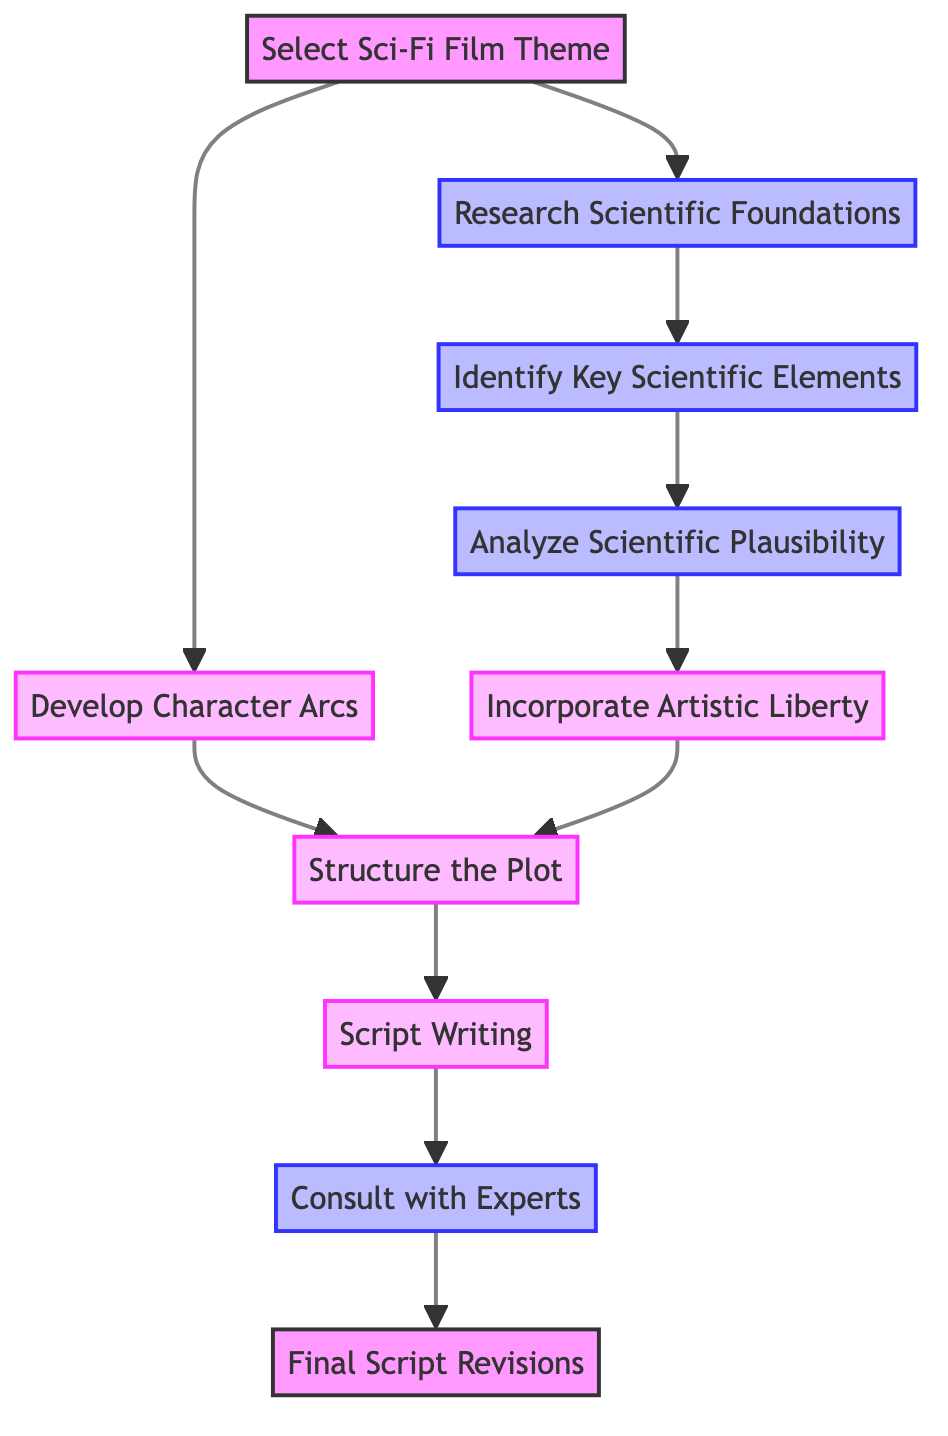What is the total number of nodes in the diagram? The diagram lists ten distinct tasks or concepts, each represented by a node labeled from 1 to 10. Therefore, by counting each node, we find there are a total of ten nodes.
Answer: 10 Which node follows "Analyze Scientific Plausibility"? From the directed edges, "Analyze Scientific Plausibility" is node 4, and the next direct connection from node 4 leads to node 5, which is "Incorporate Artistic Liberty."
Answer: Incorporate Artistic Liberty What is the primary focus of node 3? Node 3, labeled "Identify Key Scientific Elements", focuses on selecting specific scientific principles and technologies that will be central to the film's plot, such as faster-than-light travel or quantum mechanics.
Answer: Identify Key Scientific Elements How many connections lead out from "Select Sci-Fi Film Theme"? There are two directed edges leading out from "Select Sci-Fi Film Theme" (node 1): one to node 2 ("Research Scientific Foundations") and another to node 6 ("Develop Character Arcs").
Answer: 2 Which node is the final step before script revisions? The diagram shows a directed edge from node 9 ("Consult with Experts") directly leading to node 10, which is "Final Script Revisions". Hence, node 9 is the last stage before making revisions to the script.
Answer: Consult with Experts What are the two types of elements that influence the storyline as indicated in the diagram? On analyzing the diagram, it becomes clear that the elements influencing the storyline include both scientific elements (from nodes like Research Scientific Foundations) and artistic decisions (represented by Incorporate Artistic Liberty). Therefore, both scientific and artistic elements shape the narrative.
Answer: Scientific and artistic In which node is character development emphasized? The focus on character development is specifically noted in node 6, which is titled "Develop Character Arcs." It indicates that character arcs are to be made compelling by integrating them with the scientific elements of the film.
Answer: Develop Character Arcs Which nodes are classified under "artistic" within the diagram? Upon examining the classifications in the diagram, nodes 5 ("Incorporate Artistic Liberty"), 6 ("Develop Character Arcs"), 7 ("Structure the Plot"), and 8 ("Script Writing") are categorized as artistic elements.
Answer: Incorporate Artistic Liberty, Develop Character Arcs, Structure the Plot, Script Writing What is the direct relationship between "Research Scientific Foundations" and "Identify Key Scientific Elements"? The diagram clearly shows a direct edge leading from node 2 ("Research Scientific Foundations") to node 3 ("Identify Key Scientific Elements"). This indicates that after laying down the scientific foundations, the next logical step is to identify key elements to include in the film.
Answer: Identify Key Scientific Elements 